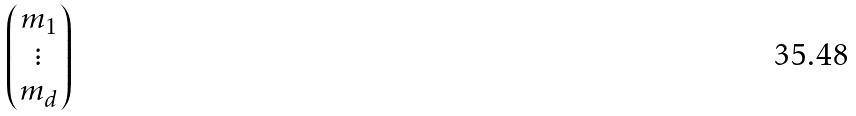Convert formula to latex. <formula><loc_0><loc_0><loc_500><loc_500>\begin{pmatrix} m _ { 1 } \\ \vdots \\ m _ { d } \end{pmatrix}</formula> 